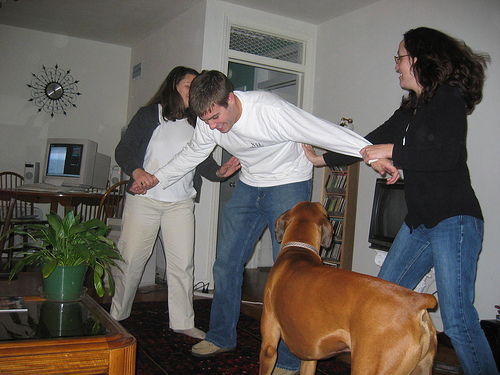<image>
Is the man on the dog? No. The man is not positioned on the dog. They may be near each other, but the man is not supported by or resting on top of the dog. Where is the man in relation to the woman? Is it to the left of the woman? No. The man is not to the left of the woman. From this viewpoint, they have a different horizontal relationship. Is the dog under the man? Yes. The dog is positioned underneath the man, with the man above it in the vertical space. 